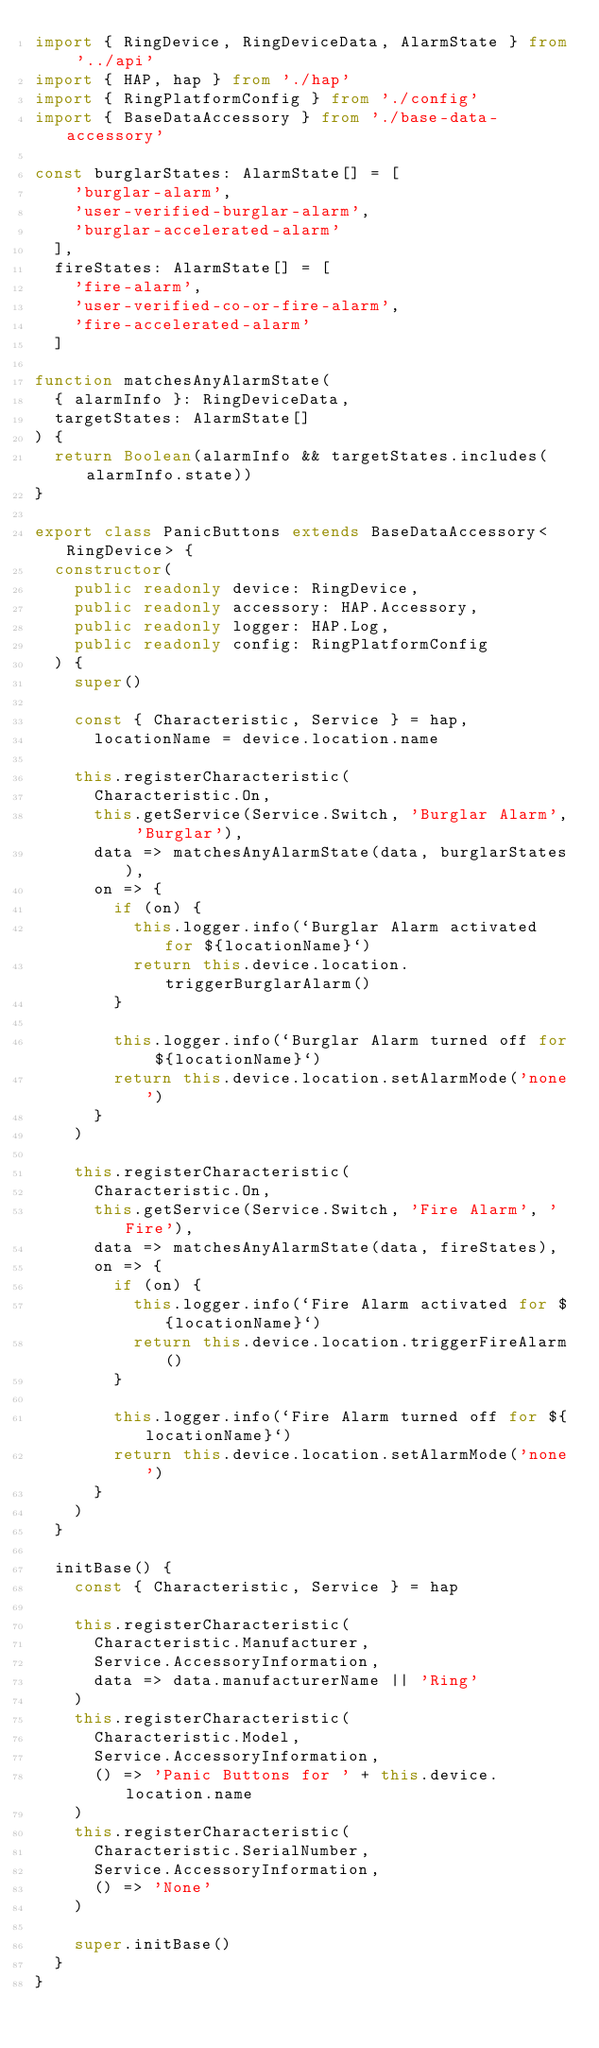<code> <loc_0><loc_0><loc_500><loc_500><_TypeScript_>import { RingDevice, RingDeviceData, AlarmState } from '../api'
import { HAP, hap } from './hap'
import { RingPlatformConfig } from './config'
import { BaseDataAccessory } from './base-data-accessory'

const burglarStates: AlarmState[] = [
    'burglar-alarm',
    'user-verified-burglar-alarm',
    'burglar-accelerated-alarm'
  ],
  fireStates: AlarmState[] = [
    'fire-alarm',
    'user-verified-co-or-fire-alarm',
    'fire-accelerated-alarm'
  ]

function matchesAnyAlarmState(
  { alarmInfo }: RingDeviceData,
  targetStates: AlarmState[]
) {
  return Boolean(alarmInfo && targetStates.includes(alarmInfo.state))
}

export class PanicButtons extends BaseDataAccessory<RingDevice> {
  constructor(
    public readonly device: RingDevice,
    public readonly accessory: HAP.Accessory,
    public readonly logger: HAP.Log,
    public readonly config: RingPlatformConfig
  ) {
    super()

    const { Characteristic, Service } = hap,
      locationName = device.location.name

    this.registerCharacteristic(
      Characteristic.On,
      this.getService(Service.Switch, 'Burglar Alarm', 'Burglar'),
      data => matchesAnyAlarmState(data, burglarStates),
      on => {
        if (on) {
          this.logger.info(`Burglar Alarm activated for ${locationName}`)
          return this.device.location.triggerBurglarAlarm()
        }

        this.logger.info(`Burglar Alarm turned off for ${locationName}`)
        return this.device.location.setAlarmMode('none')
      }
    )

    this.registerCharacteristic(
      Characteristic.On,
      this.getService(Service.Switch, 'Fire Alarm', 'Fire'),
      data => matchesAnyAlarmState(data, fireStates),
      on => {
        if (on) {
          this.logger.info(`Fire Alarm activated for ${locationName}`)
          return this.device.location.triggerFireAlarm()
        }

        this.logger.info(`Fire Alarm turned off for ${locationName}`)
        return this.device.location.setAlarmMode('none')
      }
    )
  }

  initBase() {
    const { Characteristic, Service } = hap

    this.registerCharacteristic(
      Characteristic.Manufacturer,
      Service.AccessoryInformation,
      data => data.manufacturerName || 'Ring'
    )
    this.registerCharacteristic(
      Characteristic.Model,
      Service.AccessoryInformation,
      () => 'Panic Buttons for ' + this.device.location.name
    )
    this.registerCharacteristic(
      Characteristic.SerialNumber,
      Service.AccessoryInformation,
      () => 'None'
    )

    super.initBase()
  }
}
</code> 